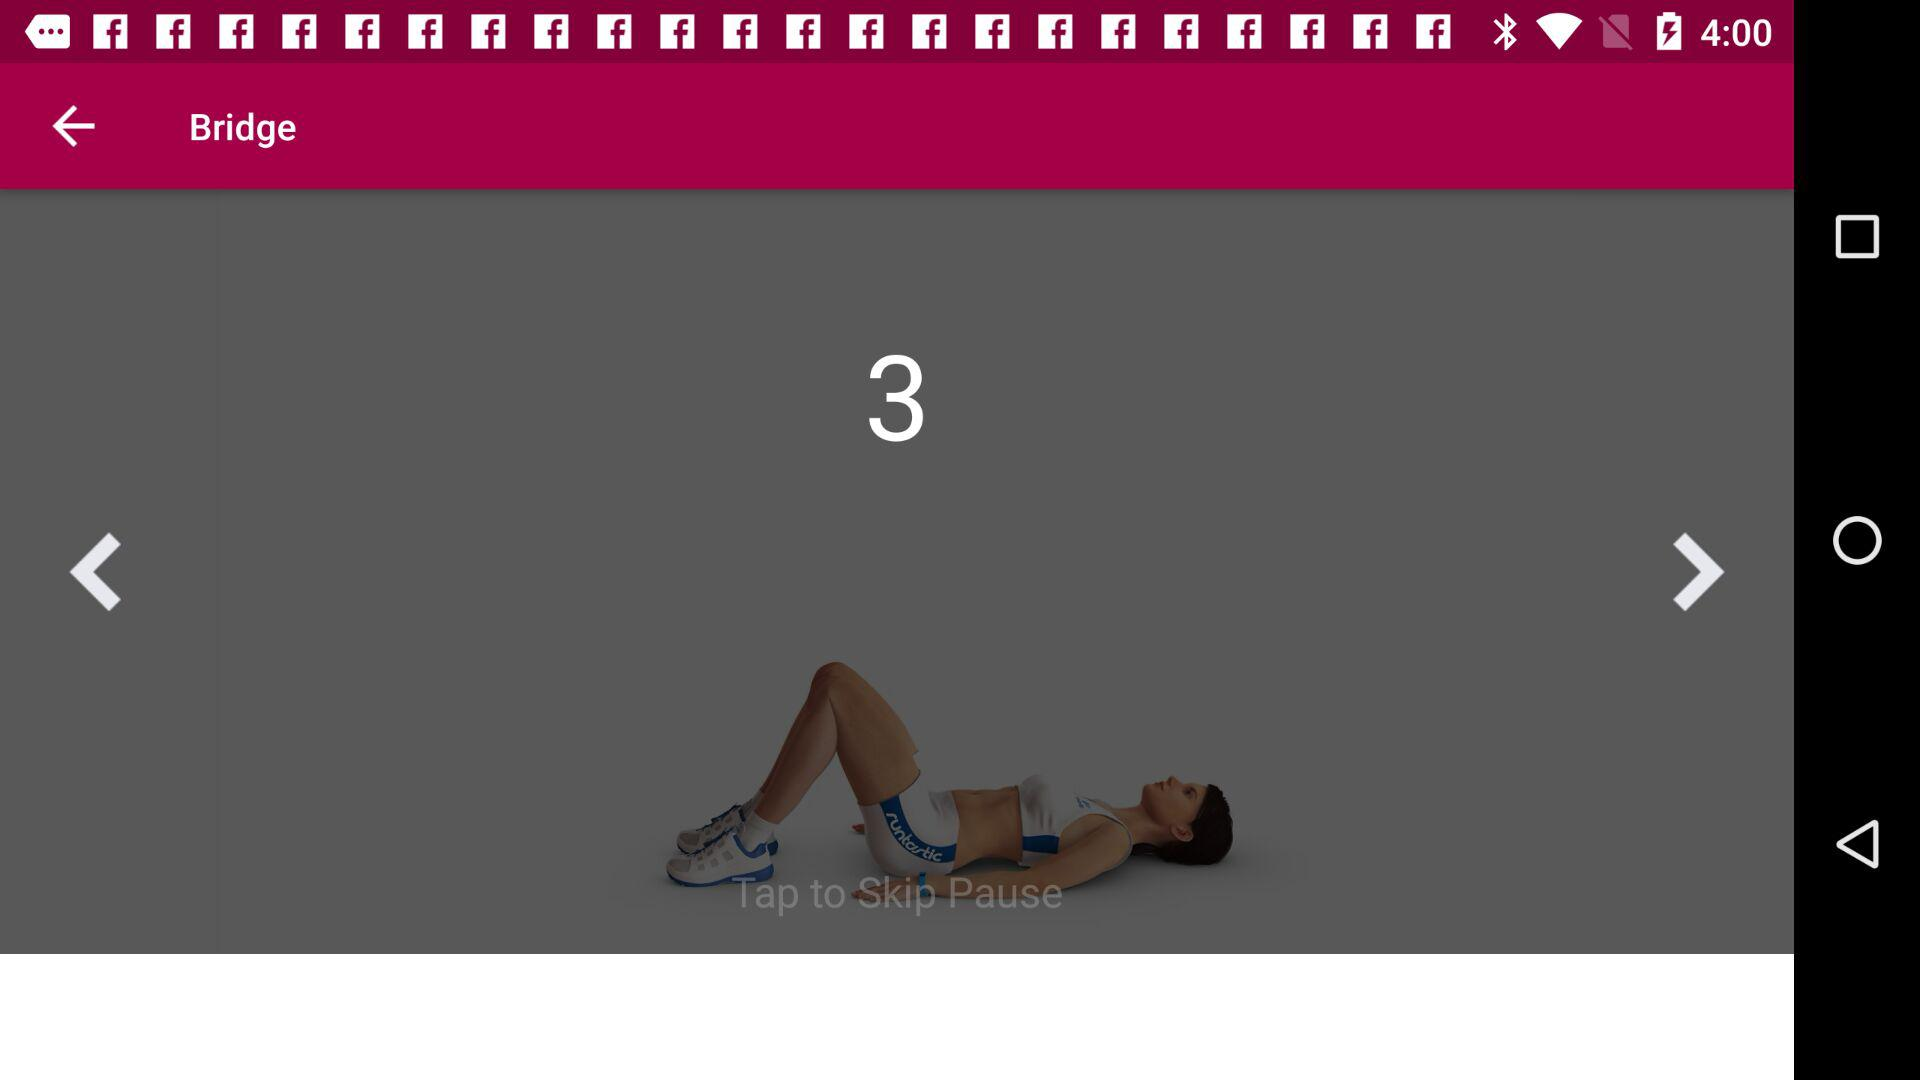What are the names of some upcoming exercises? The names of some upcoming exercises are "Plie Squat" and "Bridge". 